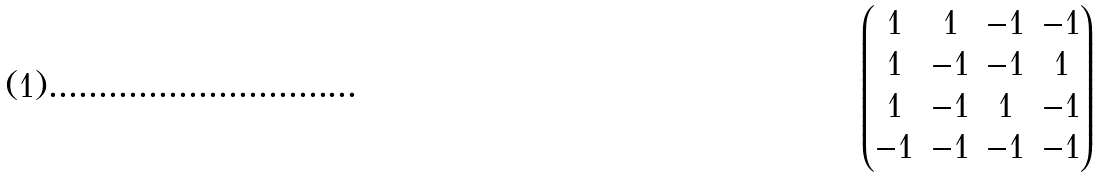<formula> <loc_0><loc_0><loc_500><loc_500>\begin{pmatrix} 1 & 1 & - 1 & - 1 \\ 1 & - 1 & - 1 & 1 \\ 1 & - 1 & 1 & - 1 \\ - 1 & - 1 & - 1 & - 1 \\ \end{pmatrix}</formula> 